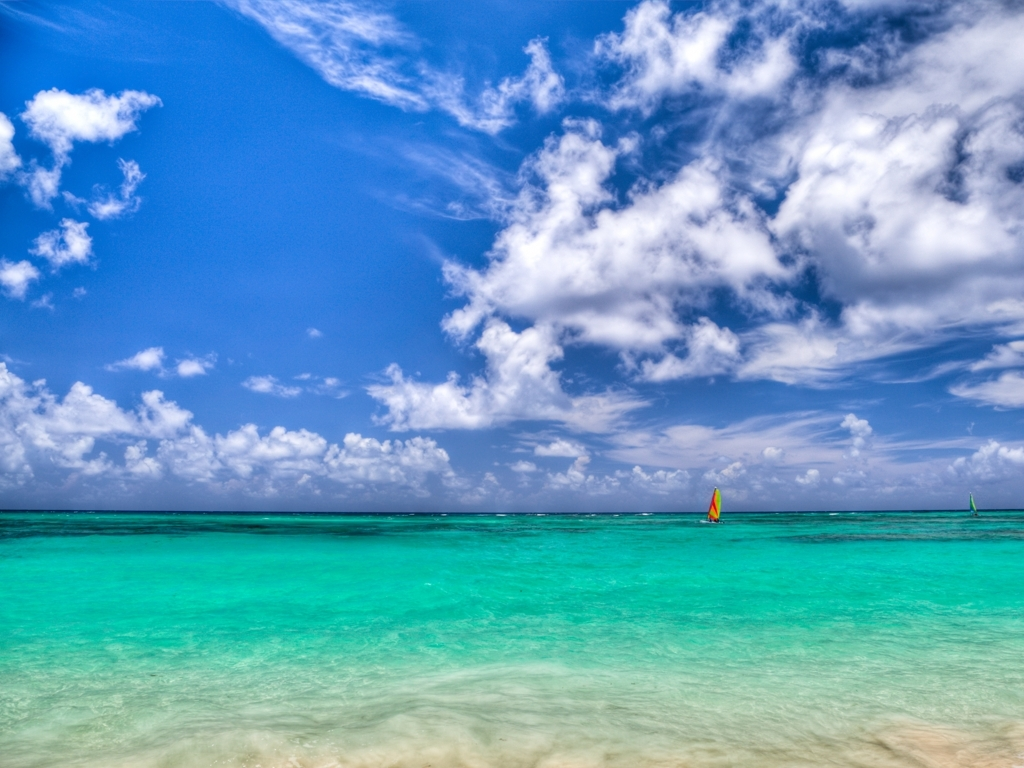How is the lighting in the image? The lighting in the image is ample and well-distributed, illuminating the ocean and sky vividly. It provides excellent visibility, enhancing the brilliant azure hues of the sea and the fluffy, cotton-like clouds, while also throwing a spotlight on the subtle gradations of color across the horizon. 